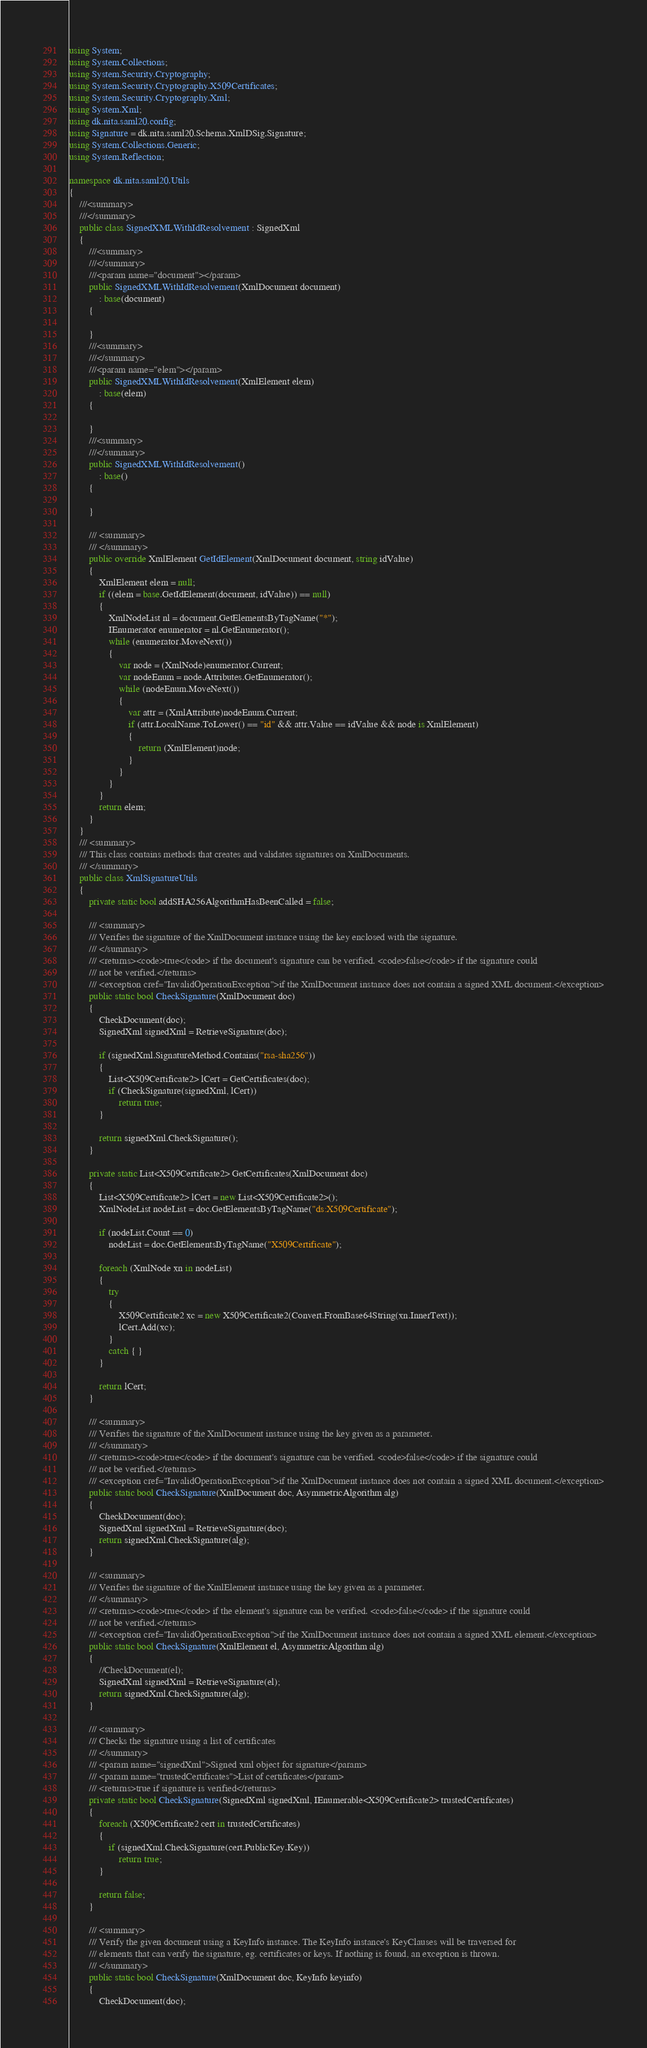Convert code to text. <code><loc_0><loc_0><loc_500><loc_500><_C#_>using System;
using System.Collections;
using System.Security.Cryptography;
using System.Security.Cryptography.X509Certificates;
using System.Security.Cryptography.Xml;
using System.Xml;
using dk.nita.saml20.config;
using Signature = dk.nita.saml20.Schema.XmlDSig.Signature;
using System.Collections.Generic;
using System.Reflection;

namespace dk.nita.saml20.Utils
{
    ///<summary>
    ///</summary>
    public class SignedXMLWithIdResolvement : SignedXml
    {
        ///<summary>
        ///</summary>
        ///<param name="document"></param>
        public SignedXMLWithIdResolvement(XmlDocument document)
            : base(document)
        {

        }
        ///<summary>
        ///</summary>
        ///<param name="elem"></param>
        public SignedXMLWithIdResolvement(XmlElement elem)
            : base(elem)
        {

        }
        ///<summary>
        ///</summary>
        public SignedXMLWithIdResolvement()
            : base()
        {

        }

        /// <summary>
        /// </summary>
        public override XmlElement GetIdElement(XmlDocument document, string idValue)
        {
            XmlElement elem = null;
            if ((elem = base.GetIdElement(document, idValue)) == null)
            {
                XmlNodeList nl = document.GetElementsByTagName("*");
                IEnumerator enumerator = nl.GetEnumerator();
                while (enumerator.MoveNext())
                {
                    var node = (XmlNode)enumerator.Current;
                    var nodeEnum = node.Attributes.GetEnumerator();
                    while (nodeEnum.MoveNext())
                    {
                        var attr = (XmlAttribute)nodeEnum.Current;
                        if (attr.LocalName.ToLower() == "id" && attr.Value == idValue && node is XmlElement)
                        {
                            return (XmlElement)node;
                        }
                    }
                }
            }
            return elem;
        }
    }
    /// <summary>
    /// This class contains methods that creates and validates signatures on XmlDocuments.
    /// </summary>
    public class XmlSignatureUtils
    {
        private static bool addSHA256AlgorithmHasBeenCalled = false;

        /// <summary>
        /// Verifies the signature of the XmlDocument instance using the key enclosed with the signature.
        /// </summary>
        /// <returns><code>true</code> if the document's signature can be verified. <code>false</code> if the signature could
        /// not be verified.</returns>
        /// <exception cref="InvalidOperationException">if the XmlDocument instance does not contain a signed XML document.</exception>
        public static bool CheckSignature(XmlDocument doc)
        {
            CheckDocument(doc);
            SignedXml signedXml = RetrieveSignature(doc);

            if (signedXml.SignatureMethod.Contains("rsa-sha256"))
            {
                List<X509Certificate2> lCert = GetCertificates(doc);
                if (CheckSignature(signedXml, lCert))
                    return true;
            }

            return signedXml.CheckSignature();
        }

        private static List<X509Certificate2> GetCertificates(XmlDocument doc)
        {
            List<X509Certificate2> lCert = new List<X509Certificate2>();
            XmlNodeList nodeList = doc.GetElementsByTagName("ds:X509Certificate");

            if (nodeList.Count == 0)
                nodeList = doc.GetElementsByTagName("X509Certificate");

            foreach (XmlNode xn in nodeList)
            {
                try
                {
                    X509Certificate2 xc = new X509Certificate2(Convert.FromBase64String(xn.InnerText));
                    lCert.Add(xc);
                }
                catch { }
            }

            return lCert;
        }

        /// <summary>
        /// Verifies the signature of the XmlDocument instance using the key given as a parameter.
        /// </summary>        
        /// <returns><code>true</code> if the document's signature can be verified. <code>false</code> if the signature could
        /// not be verified.</returns>
        /// <exception cref="InvalidOperationException">if the XmlDocument instance does not contain a signed XML document.</exception>
        public static bool CheckSignature(XmlDocument doc, AsymmetricAlgorithm alg)
        {
            CheckDocument(doc);
            SignedXml signedXml = RetrieveSignature(doc);
            return signedXml.CheckSignature(alg);
        }

        /// <summary>
        /// Verifies the signature of the XmlElement instance using the key given as a parameter.
        /// </summary>        
        /// <returns><code>true</code> if the element's signature can be verified. <code>false</code> if the signature could
        /// not be verified.</returns>
        /// <exception cref="InvalidOperationException">if the XmlDocument instance does not contain a signed XML element.</exception>
        public static bool CheckSignature(XmlElement el, AsymmetricAlgorithm alg)
        {
            //CheckDocument(el);
            SignedXml signedXml = RetrieveSignature(el);
            return signedXml.CheckSignature(alg);
        }

        /// <summary>
        /// Checks the signature using a list of certificates
        /// </summary>
        /// <param name="signedXml">Signed xml object for signature</param>
        /// <param name="trustedCertificates">List of certificates</param>
        /// <returns>true if signature is verified</returns>
        private static bool CheckSignature(SignedXml signedXml, IEnumerable<X509Certificate2> trustedCertificates)
        {
            foreach (X509Certificate2 cert in trustedCertificates)
            {
                if (signedXml.CheckSignature(cert.PublicKey.Key))
                    return true;
            }

            return false;
        }

        /// <summary>
        /// Verify the given document using a KeyInfo instance. The KeyInfo instance's KeyClauses will be traversed for 
        /// elements that can verify the signature, eg. certificates or keys. If nothing is found, an exception is thrown.
        /// </summary>
        public static bool CheckSignature(XmlDocument doc, KeyInfo keyinfo)
        {
            CheckDocument(doc);</code> 